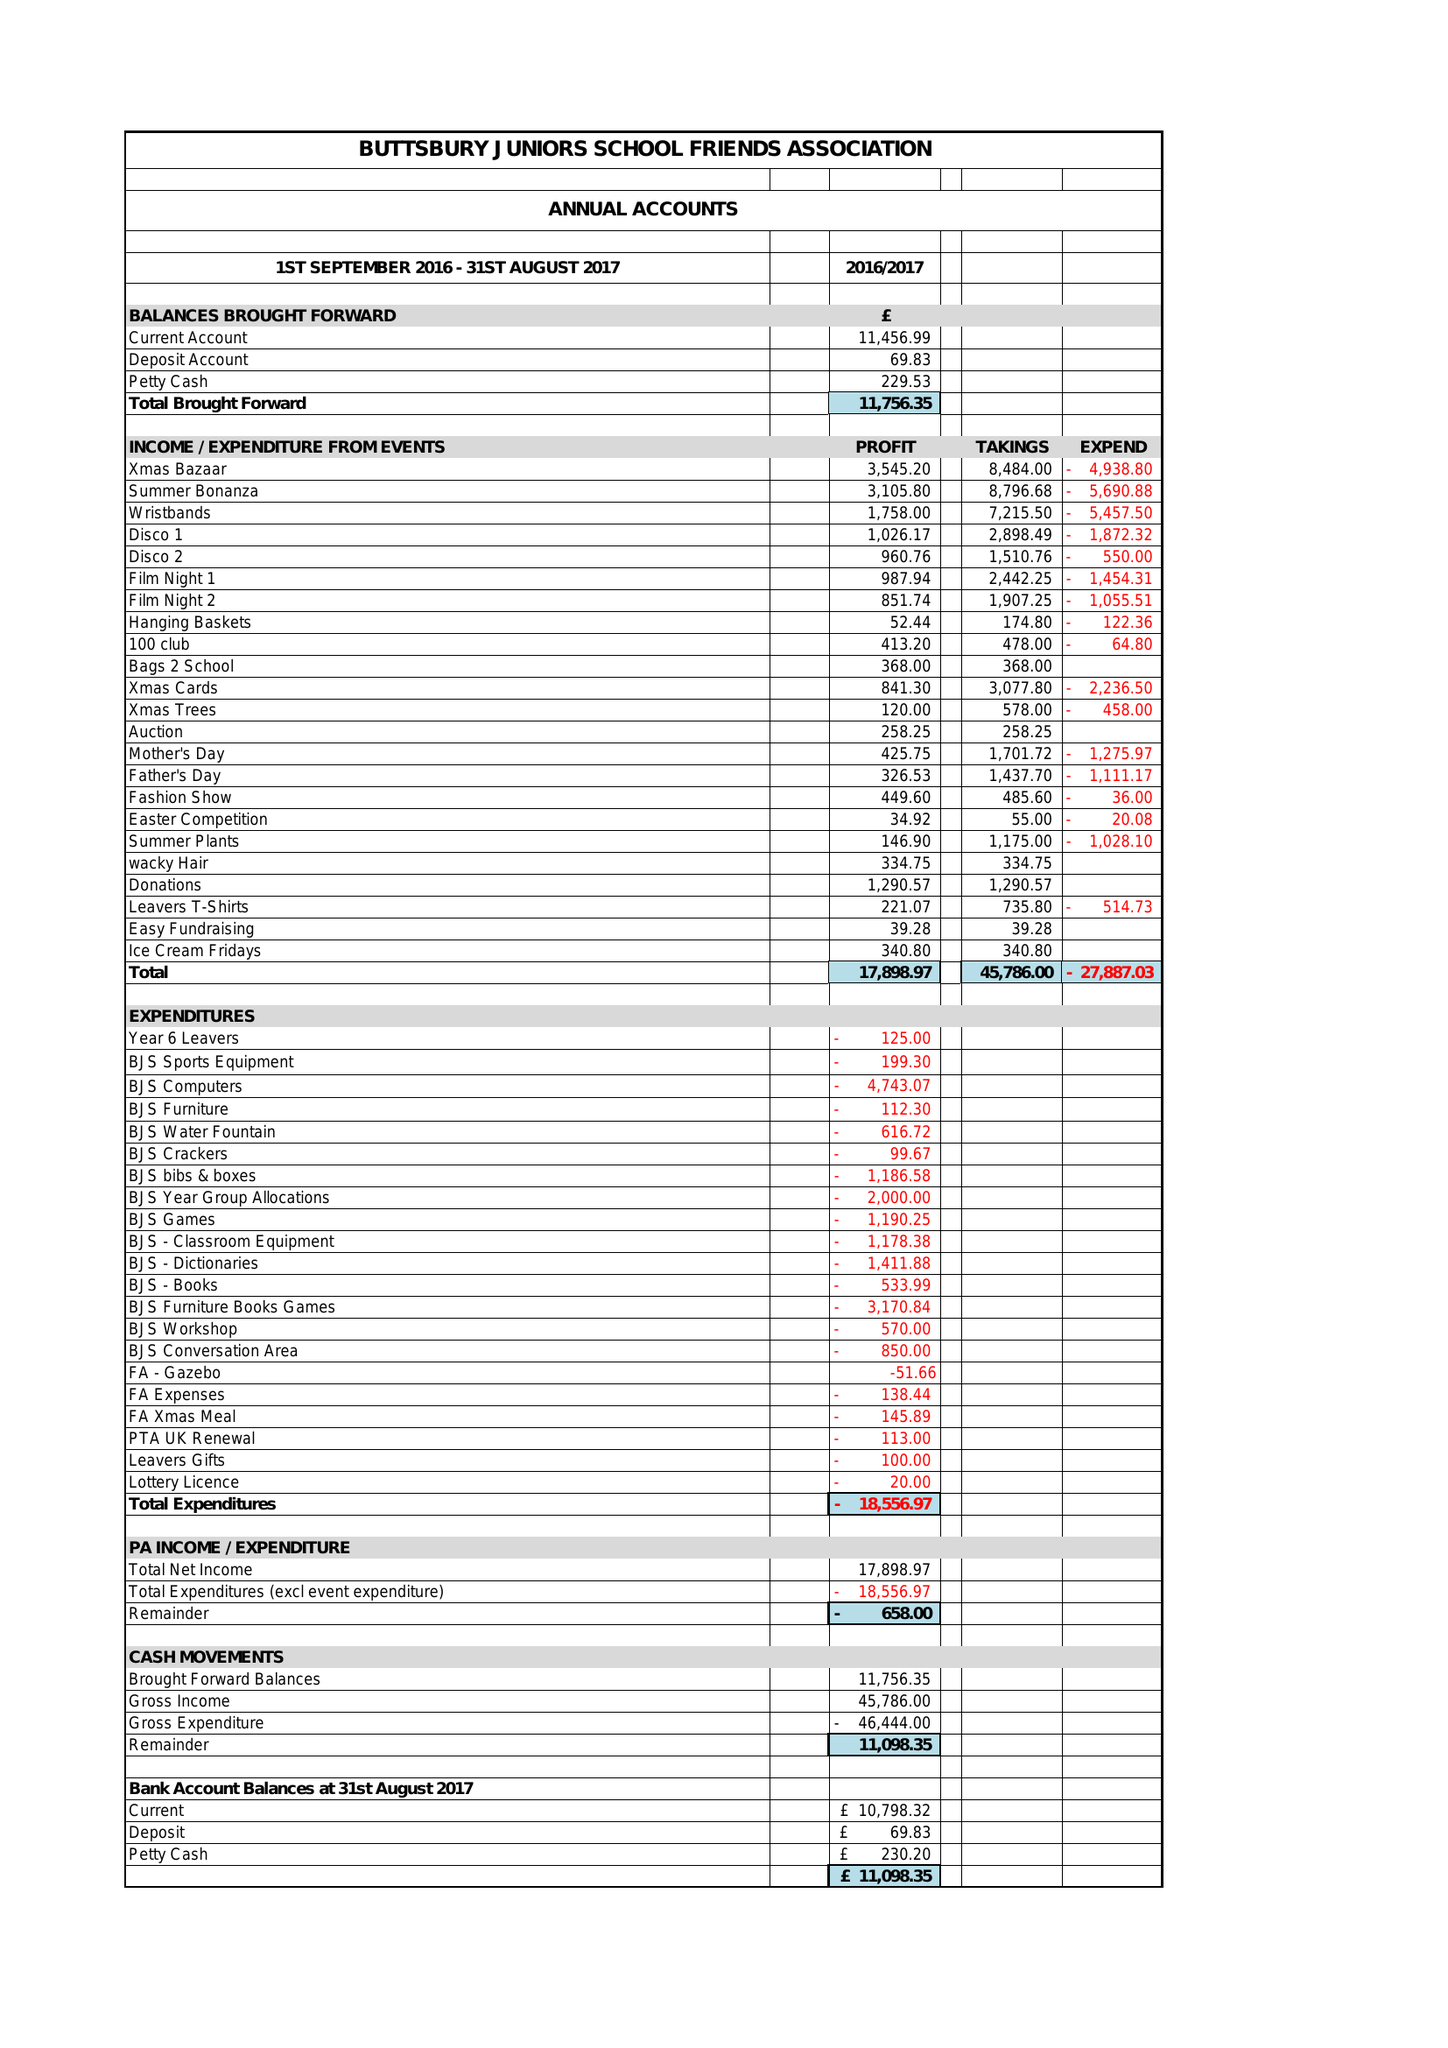What is the value for the address__postcode?
Answer the question using a single word or phrase. CM12 0SA 